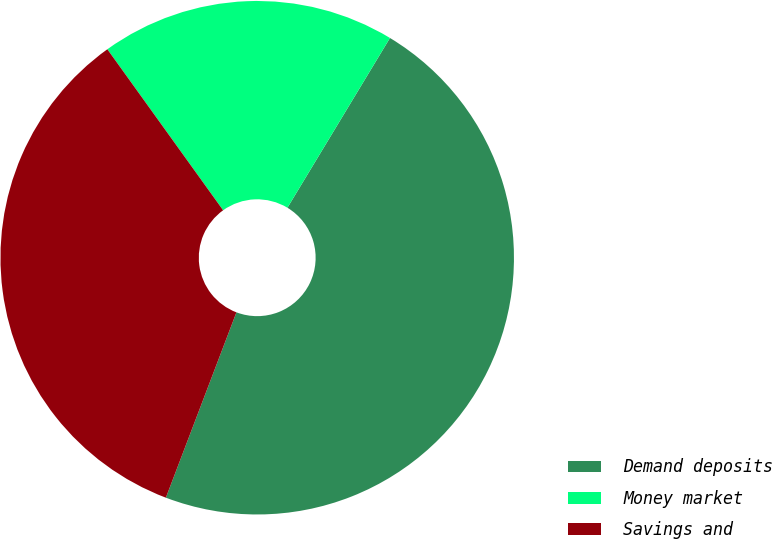Convert chart. <chart><loc_0><loc_0><loc_500><loc_500><pie_chart><fcel>Demand deposits<fcel>Money market<fcel>Savings and<nl><fcel>47.14%<fcel>18.57%<fcel>34.29%<nl></chart> 